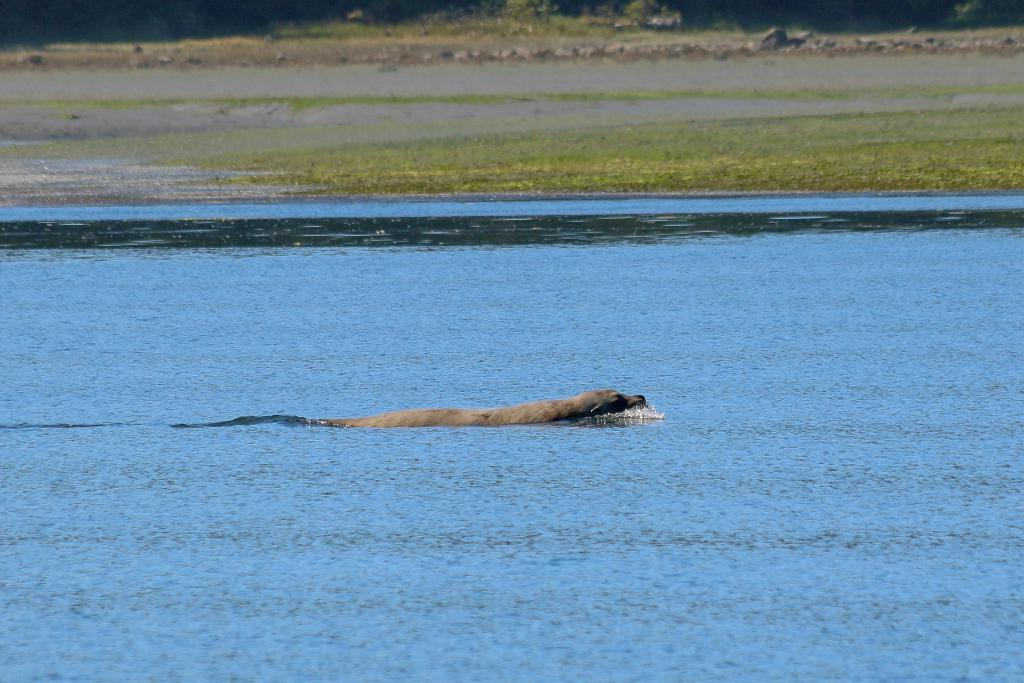What is the main subject of the image? There is an animal in the water in the image. Can you describe the animal's location in the image? The animal is in the water. What type of environment is depicted in the image? The image shows a water environment. What holiday is being celebrated in the image? There is no indication of a holiday being celebrated in the image, as it only features an animal in the water. How many times does the animal jump in the image? The provided facts do not mention the animal jumping, so it is impossible to determine how many times it jumps in the image. 